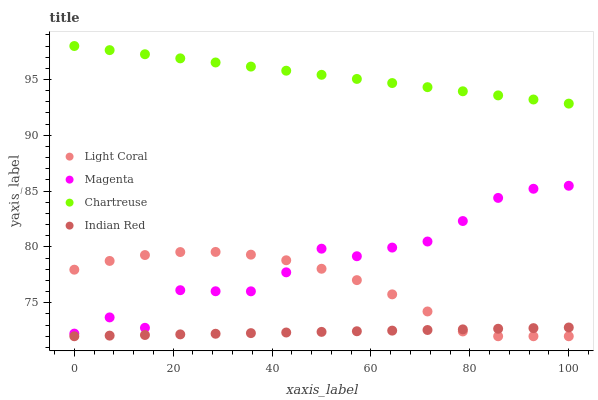Does Indian Red have the minimum area under the curve?
Answer yes or no. Yes. Does Chartreuse have the maximum area under the curve?
Answer yes or no. Yes. Does Magenta have the minimum area under the curve?
Answer yes or no. No. Does Magenta have the maximum area under the curve?
Answer yes or no. No. Is Chartreuse the smoothest?
Answer yes or no. Yes. Is Magenta the roughest?
Answer yes or no. Yes. Is Magenta the smoothest?
Answer yes or no. No. Is Chartreuse the roughest?
Answer yes or no. No. Does Light Coral have the lowest value?
Answer yes or no. Yes. Does Magenta have the lowest value?
Answer yes or no. No. Does Chartreuse have the highest value?
Answer yes or no. Yes. Does Magenta have the highest value?
Answer yes or no. No. Is Indian Red less than Chartreuse?
Answer yes or no. Yes. Is Magenta greater than Indian Red?
Answer yes or no. Yes. Does Light Coral intersect Magenta?
Answer yes or no. Yes. Is Light Coral less than Magenta?
Answer yes or no. No. Is Light Coral greater than Magenta?
Answer yes or no. No. Does Indian Red intersect Chartreuse?
Answer yes or no. No. 